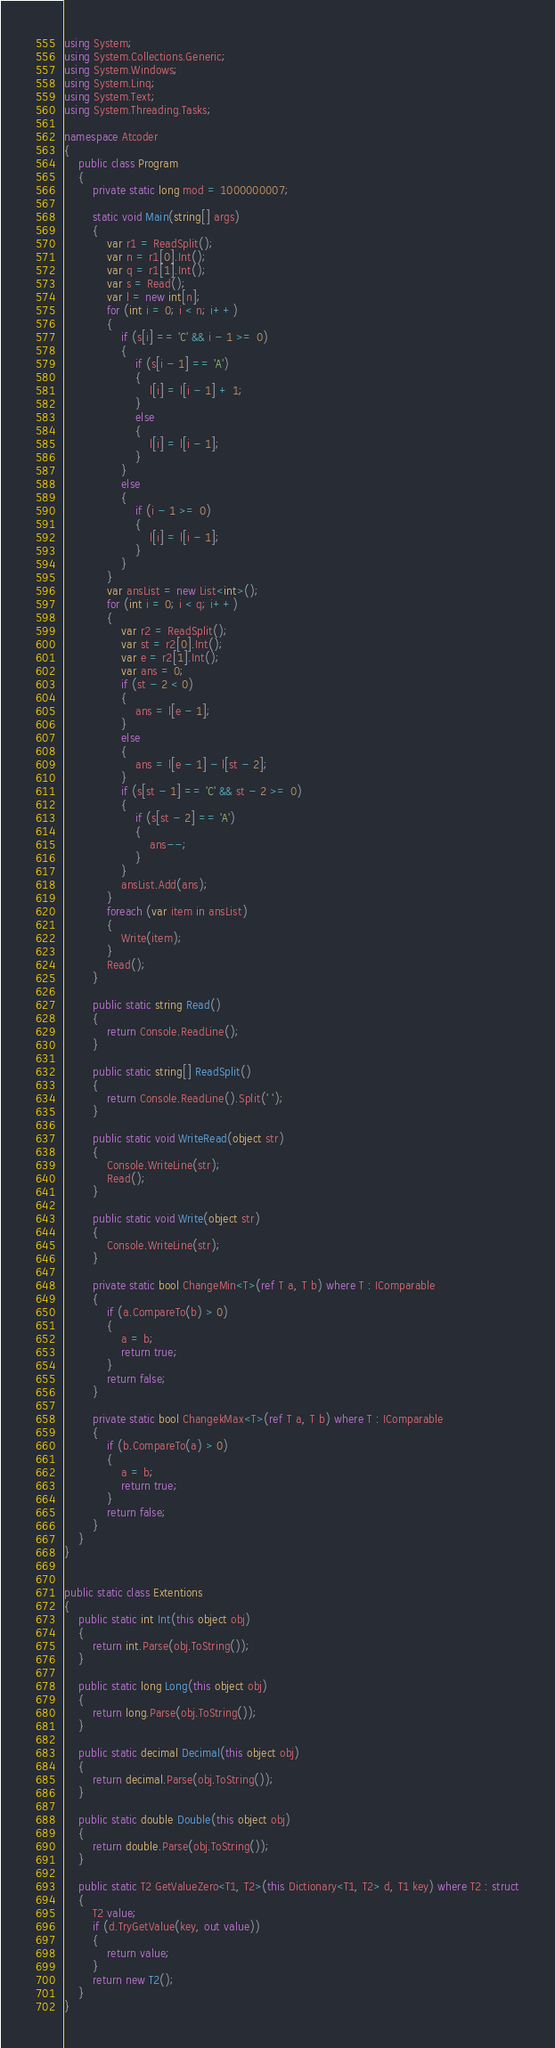<code> <loc_0><loc_0><loc_500><loc_500><_C#_>using System;
using System.Collections.Generic;
using System.Windows;
using System.Linq;
using System.Text;
using System.Threading.Tasks;

namespace Atcoder
{
    public class Program
    {
        private static long mod = 1000000007;

        static void Main(string[] args)
        {
            var r1 = ReadSplit();
            var n = r1[0].Int();
            var q = r1[1].Int();
            var s = Read();
            var l = new int[n];
            for (int i = 0; i < n; i++)
            {
                if (s[i] == 'C' && i - 1 >= 0)
                {
                    if (s[i - 1] == 'A')
                    {
                        l[i] = l[i - 1] + 1;
                    }
                    else
                    {
                        l[i] = l[i - 1];
                    }
                }
                else
                {
                    if (i - 1 >= 0)
                    {
                        l[i] = l[i - 1];
                    }
                }
            }
            var ansList = new List<int>();
            for (int i = 0; i < q; i++)
            {
                var r2 = ReadSplit();
                var st = r2[0].Int();
                var e = r2[1].Int();
                var ans = 0;
                if (st - 2 < 0)
                {
                    ans = l[e - 1];
                }
                else
                {
                    ans = l[e - 1] - l[st - 2];
                }
                if (s[st - 1] == 'C' && st - 2 >= 0)
                {
                    if (s[st - 2] == 'A')
                    {
                        ans--;
                    }
                }
                ansList.Add(ans);
            }
            foreach (var item in ansList)
            {
                Write(item);
            }
            Read();
        }
        
        public static string Read()
        {
            return Console.ReadLine();
        }

        public static string[] ReadSplit()
        {
            return Console.ReadLine().Split(' ');
        }

        public static void WriteRead(object str)
        {
            Console.WriteLine(str);
            Read();
        }

        public static void Write(object str)
        {
            Console.WriteLine(str);
        }

        private static bool ChangeMin<T>(ref T a, T b) where T : IComparable
        {
            if (a.CompareTo(b) > 0)
            {
                a = b;
                return true;
            }
            return false;
        }

        private static bool ChangekMax<T>(ref T a, T b) where T : IComparable
        {
            if (b.CompareTo(a) > 0)
            {
                a = b;
                return true;
            }
            return false;
        }
    }
}


public static class Extentions
{
    public static int Int(this object obj)
    {
        return int.Parse(obj.ToString());
    }

    public static long Long(this object obj)
    {
        return long.Parse(obj.ToString());
    }

    public static decimal Decimal(this object obj)
    {
        return decimal.Parse(obj.ToString());
    }

    public static double Double(this object obj)
    {
        return double.Parse(obj.ToString());
    }

    public static T2 GetValueZero<T1, T2>(this Dictionary<T1, T2> d, T1 key) where T2 : struct
    {
        T2 value;
        if (d.TryGetValue(key, out value))
        {
            return value;
        }
        return new T2();
    }
}

</code> 